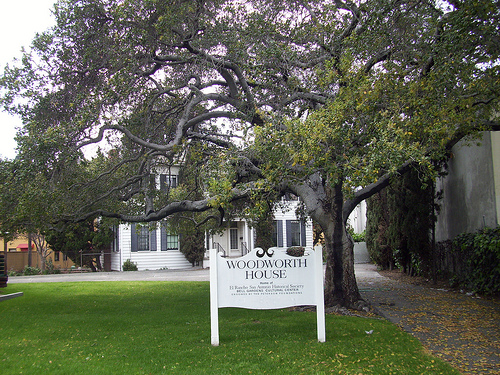<image>
Is the grass behind the house? Yes. From this viewpoint, the grass is positioned behind the house, with the house partially or fully occluding the grass. 